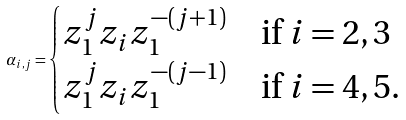Convert formula to latex. <formula><loc_0><loc_0><loc_500><loc_500>\alpha _ { i , j } = \begin{cases} z _ { 1 } ^ { j } z _ { i } z _ { 1 } ^ { - ( j + 1 ) } & \text {if $i=2,3$} \\ z _ { 1 } ^ { j } z _ { i } z _ { 1 } ^ { - ( j - 1 ) } & \text {if $i=4,5$.} \end{cases}</formula> 